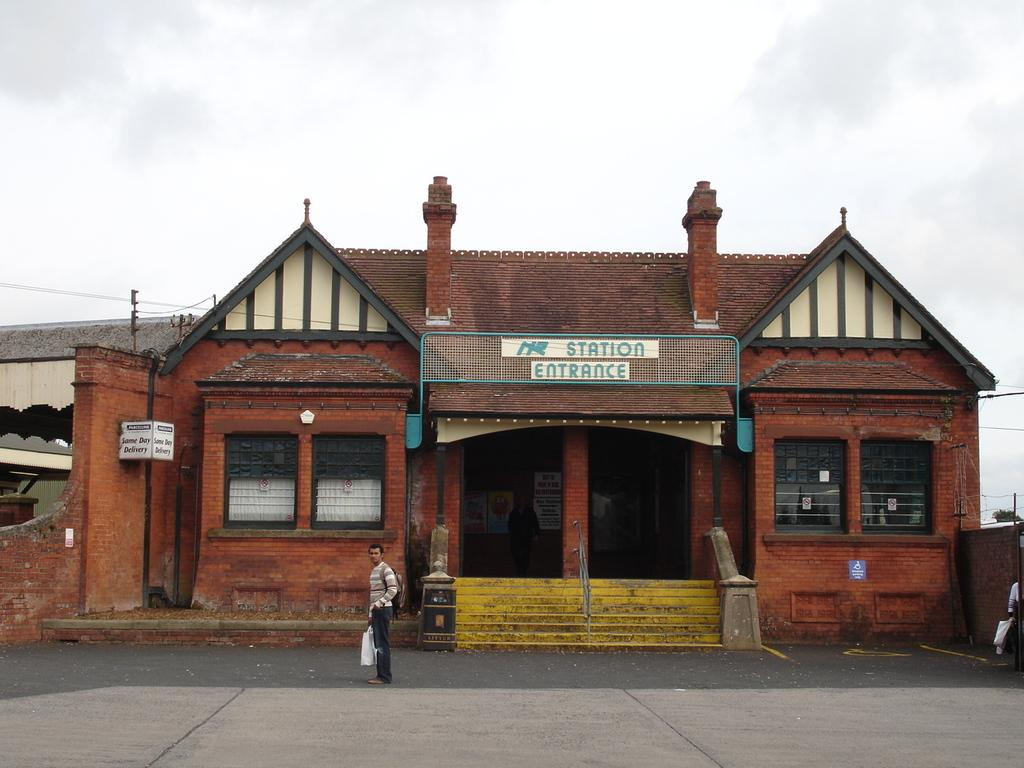What is the main subject in the foreground of the image? There is a house entrance and a person standing on the road in the foreground of the image. What is the weather like in the image? The image is taken during a sunny day. Where is the image taken in relation to a platform? The image is taken near a platform. What can be seen in the background of the image? The sky is visible in the background of the image. How does the person in the image increase the temperature during the night? The person in the image does not increase the temperature during the night, as the image is taken during a sunny day. 